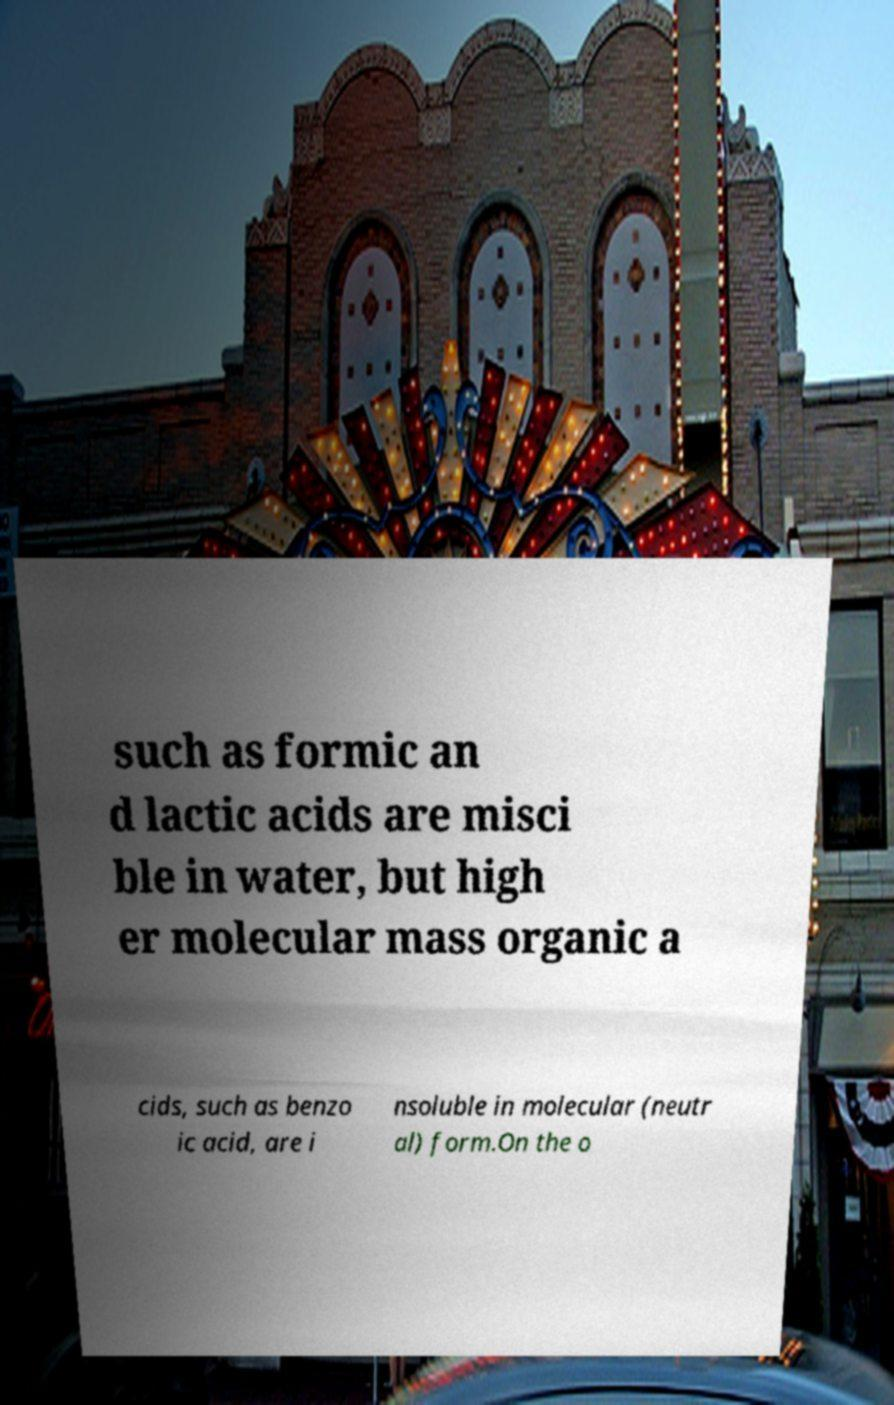Please read and relay the text visible in this image. What does it say? such as formic an d lactic acids are misci ble in water, but high er molecular mass organic a cids, such as benzo ic acid, are i nsoluble in molecular (neutr al) form.On the o 